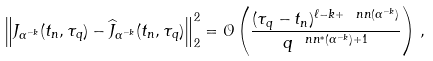Convert formula to latex. <formula><loc_0><loc_0><loc_500><loc_500>\left \| J _ { \alpha ^ { - k } } ( t _ { n } , \tau _ { q } ) - \widehat { J } _ { \alpha ^ { - k } } ( t _ { n } , \tau _ { q } ) \right \| _ { 2 } ^ { 2 } = \mathcal { O } \left ( \frac { ( \tau _ { q } - t _ { n } ) ^ { \ell - k + \ n n ( \alpha ^ { - k } ) } } { q ^ { \ n n ^ { * } ( \alpha ^ { - k } ) + 1 } } \right ) \, ,</formula> 